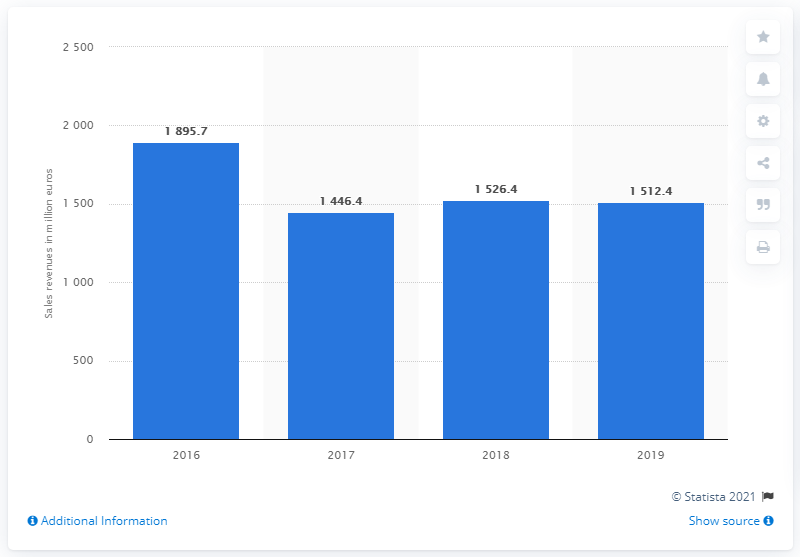Outline some significant characteristics in this image. In 2019, Lavazza's revenue was 1512.4 million. 